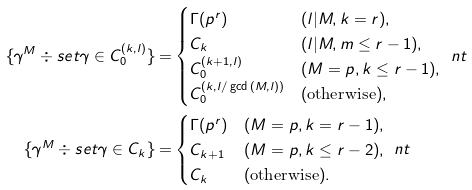<formula> <loc_0><loc_0><loc_500><loc_500>\{ \gamma ^ { M } \div s e t \gamma \in C _ { 0 } ^ { ( k , l ) } \} = & \begin{cases} \Gamma ( p ^ { r } ) & ( l | M , k = r ) , \\ C _ { k } & ( l | M , m \leq r - 1 ) , \\ C _ { 0 } ^ { ( k + 1 , l ) } & ( M = p , k \leq r - 1 ) , \\ C _ { 0 } ^ { ( k , l / \gcd { ( M , l ) } ) } & ( \text {otherwise} ) , \end{cases} \ n t \\ \{ \gamma ^ { M } \div s e t \gamma \in C _ { k } \} = & \begin{cases} \Gamma ( p ^ { r } ) & ( M = p , k = r - 1 ) , \\ C _ { k + 1 } & ( M = p , k \leq r - 2 ) , \\ C _ { k } & ( \text {otherwise} ) . \end{cases} \ n t</formula> 